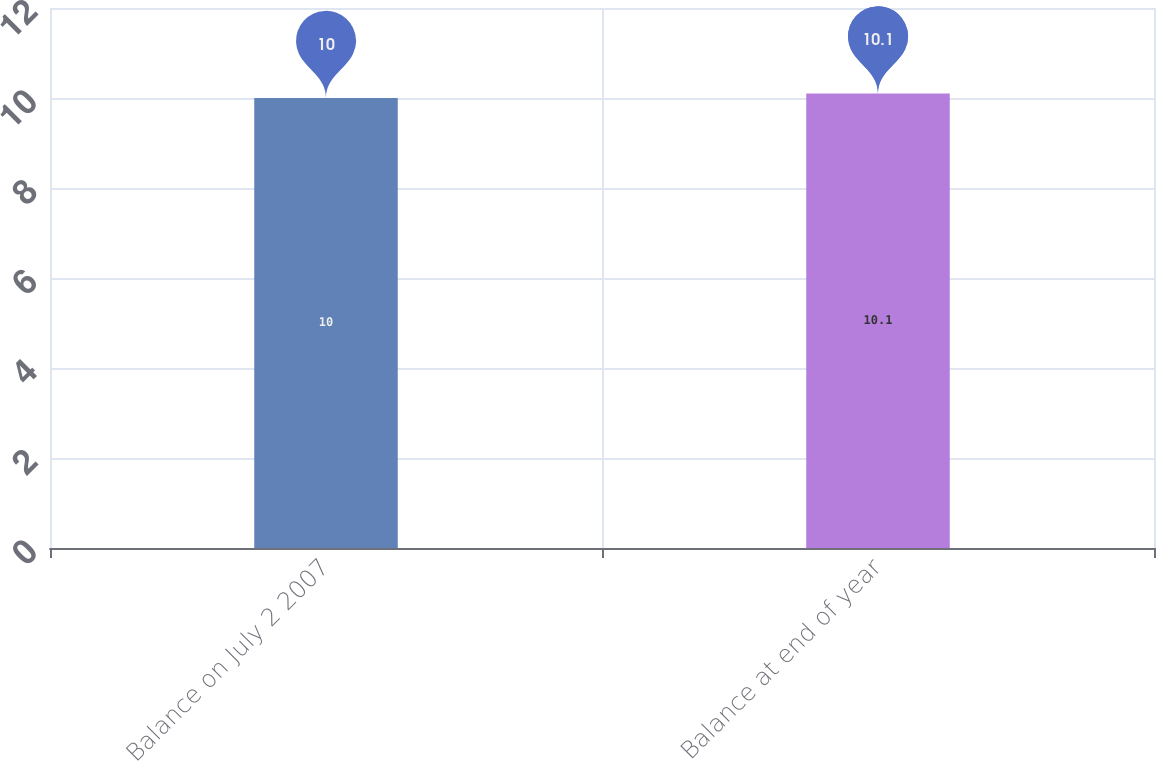<chart> <loc_0><loc_0><loc_500><loc_500><bar_chart><fcel>Balance on July 2 2007<fcel>Balance at end of year<nl><fcel>10<fcel>10.1<nl></chart> 